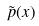<formula> <loc_0><loc_0><loc_500><loc_500>\tilde { p } ( x )</formula> 